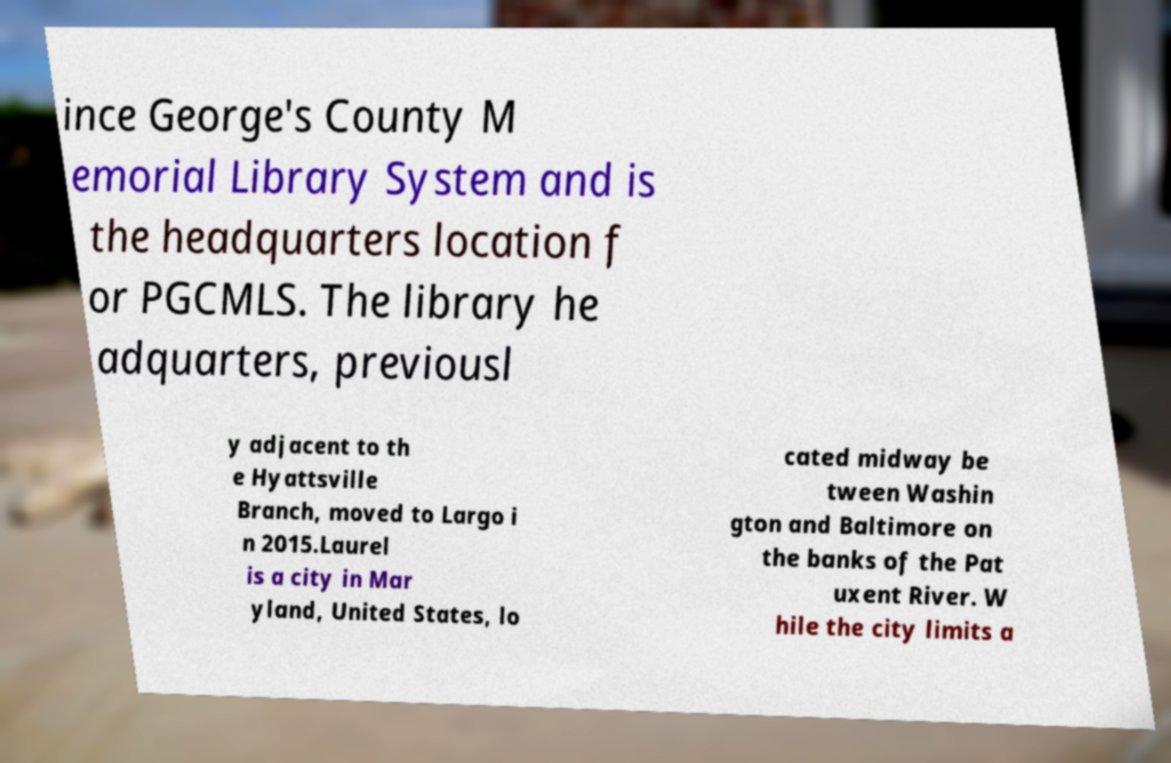For documentation purposes, I need the text within this image transcribed. Could you provide that? ince George's County M emorial Library System and is the headquarters location f or PGCMLS. The library he adquarters, previousl y adjacent to th e Hyattsville Branch, moved to Largo i n 2015.Laurel is a city in Mar yland, United States, lo cated midway be tween Washin gton and Baltimore on the banks of the Pat uxent River. W hile the city limits a 